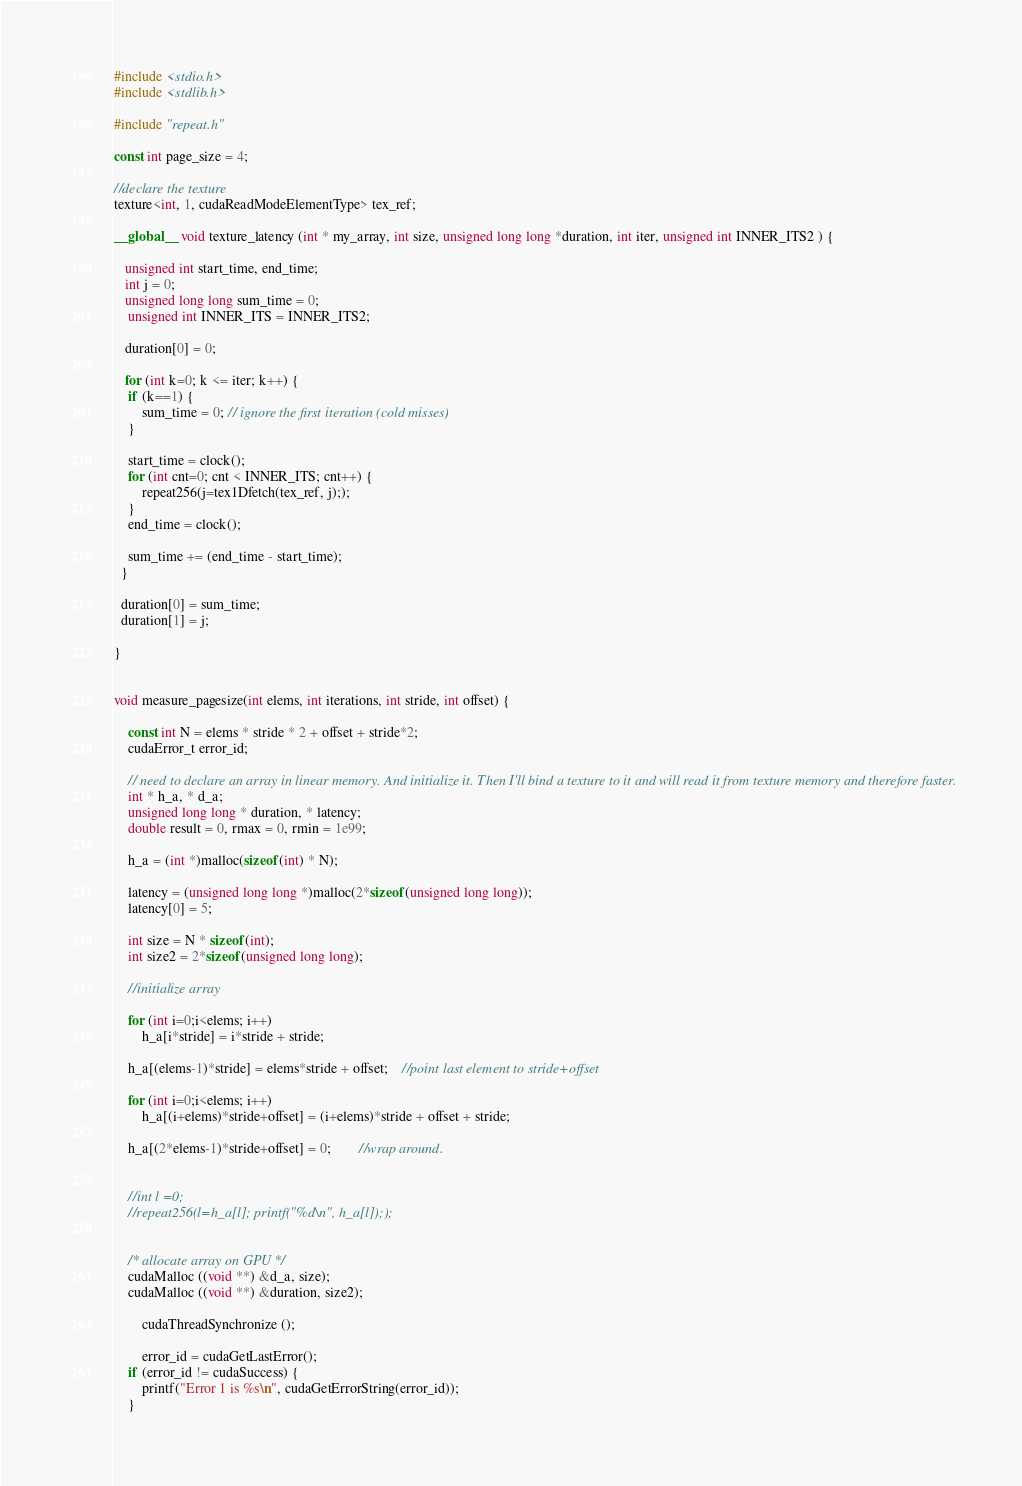Convert code to text. <code><loc_0><loc_0><loc_500><loc_500><_Cuda_>#include <stdio.h>
#include <stdlib.h>

#include "repeat.h"

const int page_size = 4;

//declare the texture
texture<int, 1, cudaReadModeElementType> tex_ref; 

__global__ void texture_latency (int * my_array, int size, unsigned long long *duration, int iter, unsigned int INNER_ITS2 ) {

   unsigned int start_time, end_time;
   int j = 0;
   unsigned long long sum_time = 0;
	unsigned int INNER_ITS = INNER_ITS2;

   duration[0] = 0;

   for (int k=0; k <= iter; k++) {
  	if (k==1) {
		sum_time = 0; // ignore the first iteration (cold misses)
	}

	start_time = clock();
	for (int cnt=0; cnt < INNER_ITS; cnt++) {
   		repeat256(j=tex1Dfetch(tex_ref, j););
	}
   	end_time = clock();

	sum_time += (end_time - start_time);
  }

  duration[0] = sum_time;
  duration[1] = j;

}


void measure_pagesize(int elems, int iterations, int stride, int offset) {

	const int N = elems * stride * 2 + offset + stride*2;
	cudaError_t error_id;

	// need to declare an array in linear memory. And initialize it. Then I'll bind a texture to it and will read it from texture memory and therefore faster.
	int * h_a, * d_a;
	unsigned long long * duration, * latency;
	double result = 0, rmax = 0, rmin = 1e99;

	h_a = (int *)malloc(sizeof(int) * N);

	latency = (unsigned long long *)malloc(2*sizeof(unsigned long long));
	latency[0] = 5;

	int size = N * sizeof(int);
	int size2 = 2*sizeof(unsigned long long);

	//initialize array
	
	for (int i=0;i<elems; i++)
		h_a[i*stride] = i*stride + stride;

	h_a[(elems-1)*stride] = elems*stride + offset;	//point last element to stride+offset

	for (int i=0;i<elems; i++)
		h_a[(i+elems)*stride+offset] = (i+elems)*stride + offset + stride;

	h_a[(2*elems-1)*stride+offset] = 0;		//wrap around.


	//int l =0;
	//repeat256(l=h_a[l]; printf("%d\n", h_a[l]););


	/* allocate array on GPU */
	cudaMalloc ((void **) &d_a, size);
	cudaMalloc ((void **) &duration, size2);

        cudaThreadSynchronize ();

        error_id = cudaGetLastError();
	if (error_id != cudaSuccess) {
		printf("Error 1 is %s\n", cudaGetErrorString(error_id));
	}

</code> 